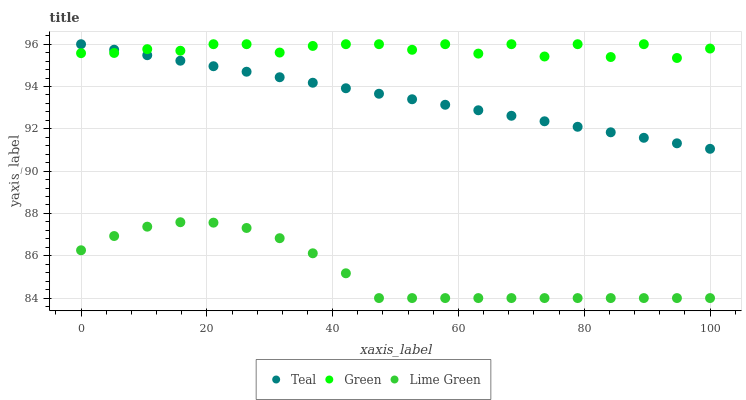Does Lime Green have the minimum area under the curve?
Answer yes or no. Yes. Does Green have the maximum area under the curve?
Answer yes or no. Yes. Does Teal have the minimum area under the curve?
Answer yes or no. No. Does Teal have the maximum area under the curve?
Answer yes or no. No. Is Teal the smoothest?
Answer yes or no. Yes. Is Green the roughest?
Answer yes or no. Yes. Is Green the smoothest?
Answer yes or no. No. Is Teal the roughest?
Answer yes or no. No. Does Lime Green have the lowest value?
Answer yes or no. Yes. Does Teal have the lowest value?
Answer yes or no. No. Does Teal have the highest value?
Answer yes or no. Yes. Is Lime Green less than Green?
Answer yes or no. Yes. Is Green greater than Lime Green?
Answer yes or no. Yes. Does Teal intersect Green?
Answer yes or no. Yes. Is Teal less than Green?
Answer yes or no. No. Is Teal greater than Green?
Answer yes or no. No. Does Lime Green intersect Green?
Answer yes or no. No. 